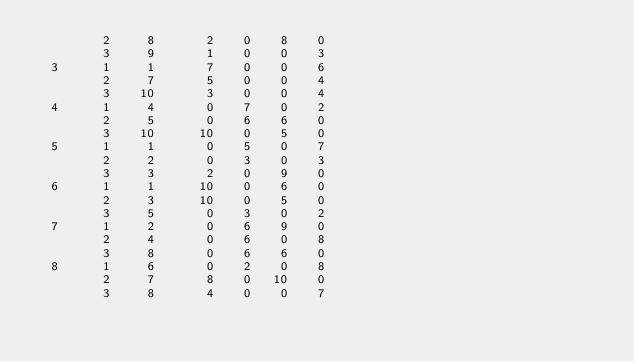Convert code to text. <code><loc_0><loc_0><loc_500><loc_500><_ObjectiveC_>         2     8       2    0    8    0
         3     9       1    0    0    3
  3      1     1       7    0    0    6
         2     7       5    0    0    4
         3    10       3    0    0    4
  4      1     4       0    7    0    2
         2     5       0    6    6    0
         3    10      10    0    5    0
  5      1     1       0    5    0    7
         2     2       0    3    0    3
         3     3       2    0    9    0
  6      1     1      10    0    6    0
         2     3      10    0    5    0
         3     5       0    3    0    2
  7      1     2       0    6    9    0
         2     4       0    6    0    8
         3     8       0    6    6    0
  8      1     6       0    2    0    8
         2     7       8    0   10    0
         3     8       4    0    0    7</code> 